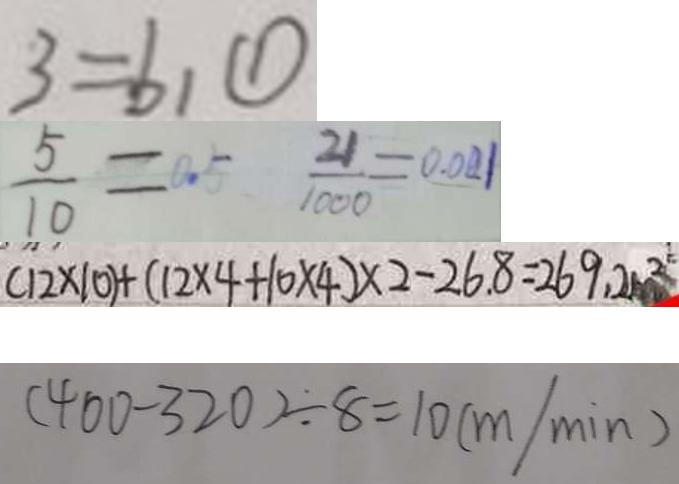<formula> <loc_0><loc_0><loc_500><loc_500>3 = b _ { 1 } \textcircled { 1 } 
 \frac { 5 } { 1 0 } = 0 . 5 \frac { 2 1 } { 1 0 0 0 } = 0 . 0 2 1 
 ( 1 2 \times 1 0 ) + ( 1 2 \times 4 + 1 0 \times 4 ) \times 2 - 2 6 . 8 = 2 6 9 . 2 m ^ { 2 } 
 ( 4 0 0 - 3 2 0 ) \div 8 = 1 0 ( m / \min )</formula> 